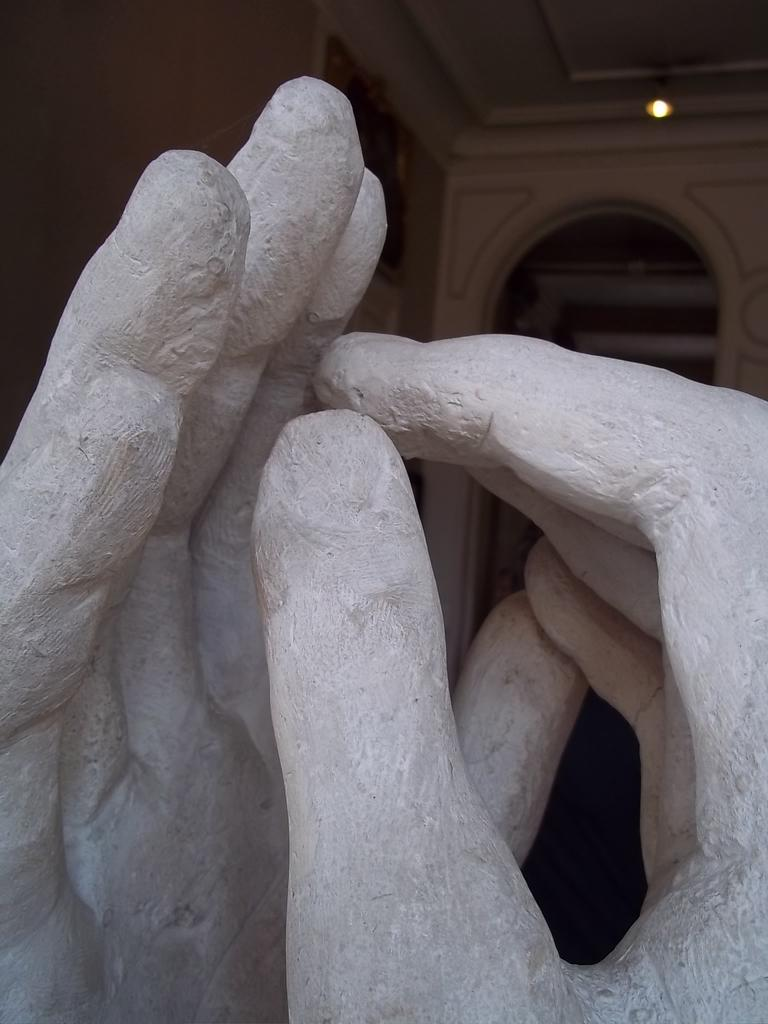What is the main subject of the image? There is a sculpture in the image. What type of structure can be seen in the background? There is a wall visible in the image. What part of a building is visible above the wall? There is a roof visible in the image. How many dogs are wearing veils in the image? There are no dogs or veils present in the image. What type of apples can be seen growing on the sculpture in the image? There are no apples present on the sculpture in the image. 